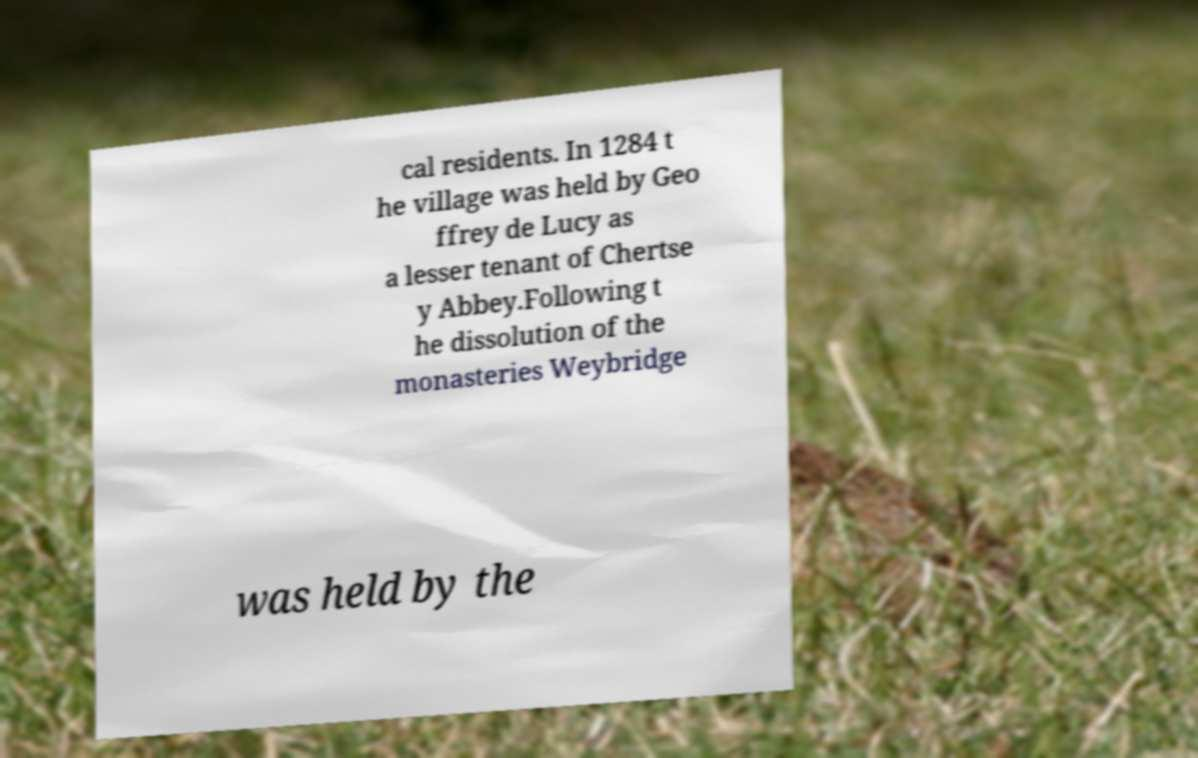Can you accurately transcribe the text from the provided image for me? cal residents. In 1284 t he village was held by Geo ffrey de Lucy as a lesser tenant of Chertse y Abbey.Following t he dissolution of the monasteries Weybridge was held by the 